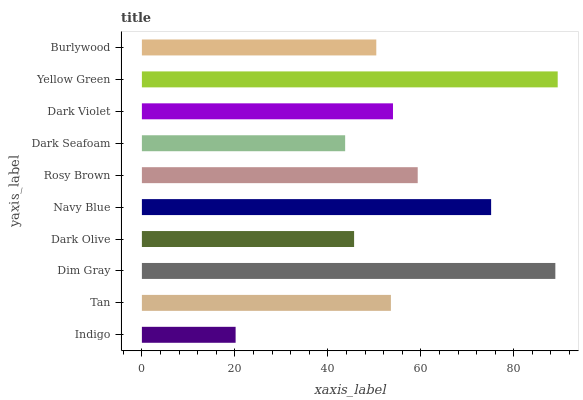Is Indigo the minimum?
Answer yes or no. Yes. Is Yellow Green the maximum?
Answer yes or no. Yes. Is Tan the minimum?
Answer yes or no. No. Is Tan the maximum?
Answer yes or no. No. Is Tan greater than Indigo?
Answer yes or no. Yes. Is Indigo less than Tan?
Answer yes or no. Yes. Is Indigo greater than Tan?
Answer yes or no. No. Is Tan less than Indigo?
Answer yes or no. No. Is Dark Violet the high median?
Answer yes or no. Yes. Is Tan the low median?
Answer yes or no. Yes. Is Indigo the high median?
Answer yes or no. No. Is Dim Gray the low median?
Answer yes or no. No. 